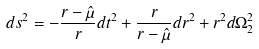<formula> <loc_0><loc_0><loc_500><loc_500>d s ^ { 2 } = - { \frac { r - \hat { \mu } } { r } } d t ^ { 2 } + { \frac { r } { r - \hat { \mu } } } d r ^ { 2 } + r ^ { 2 } d \Omega _ { 2 } ^ { 2 }</formula> 